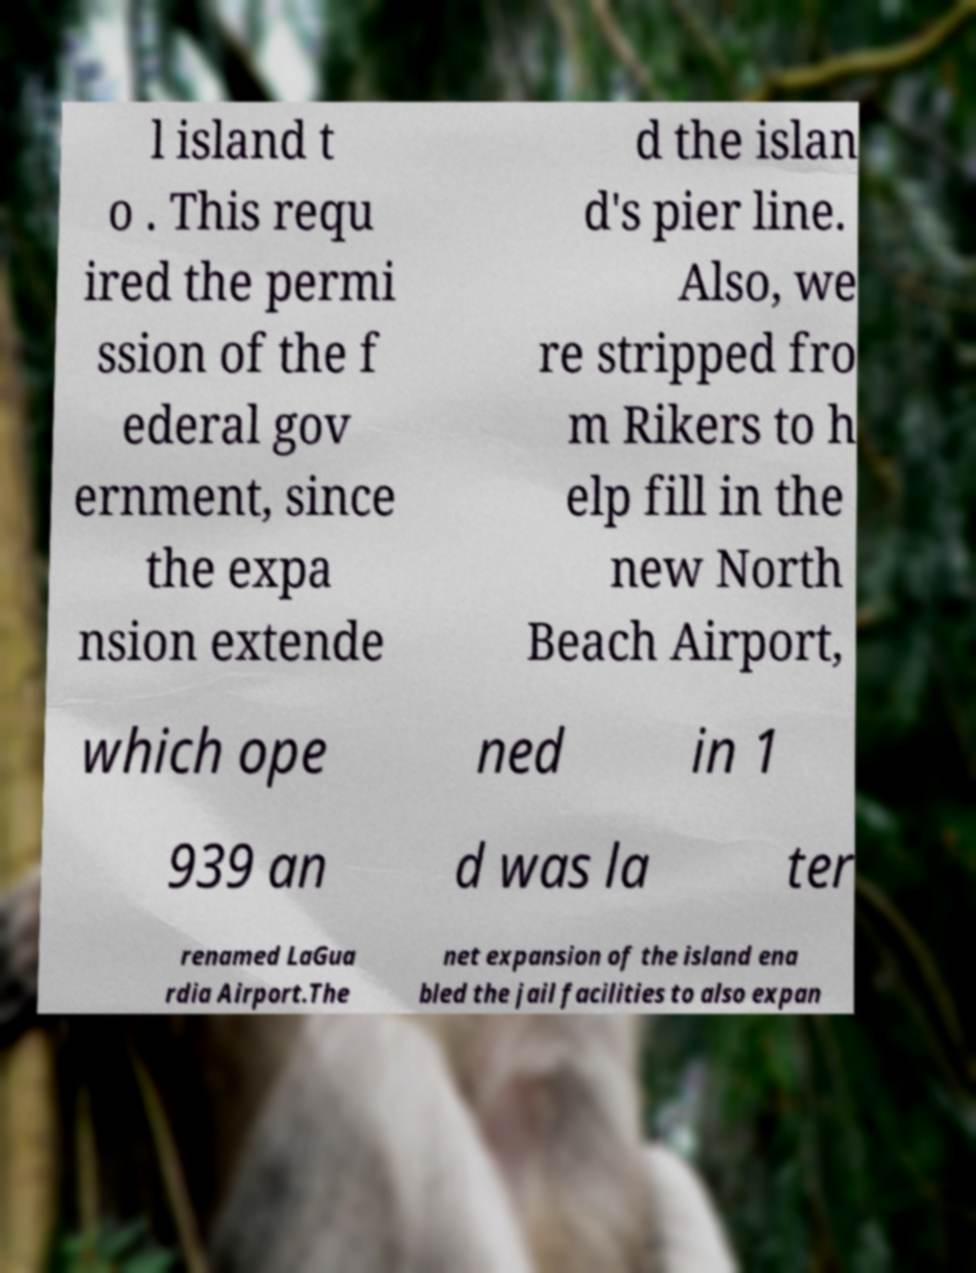Can you accurately transcribe the text from the provided image for me? l island t o . This requ ired the permi ssion of the f ederal gov ernment, since the expa nsion extende d the islan d's pier line. Also, we re stripped fro m Rikers to h elp fill in the new North Beach Airport, which ope ned in 1 939 an d was la ter renamed LaGua rdia Airport.The net expansion of the island ena bled the jail facilities to also expan 